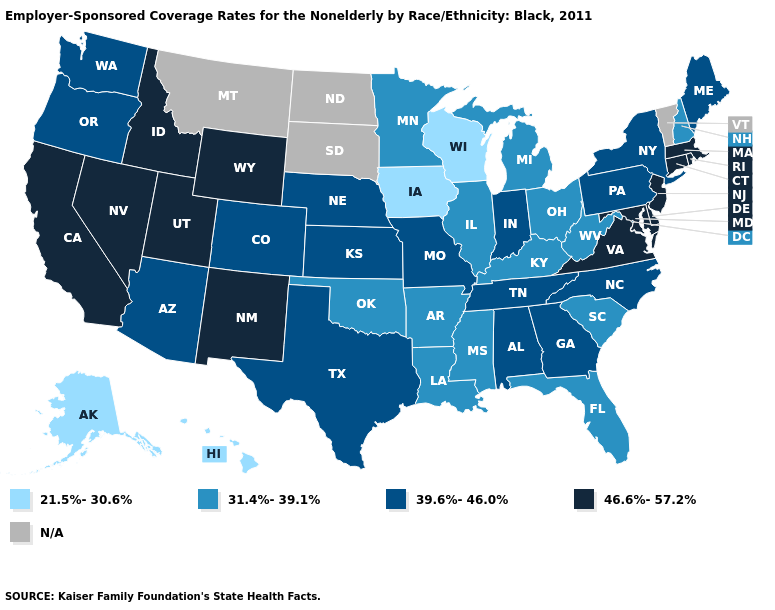Which states have the lowest value in the USA?
Keep it brief. Alaska, Hawaii, Iowa, Wisconsin. Among the states that border New Mexico , does Utah have the lowest value?
Keep it brief. No. How many symbols are there in the legend?
Quick response, please. 5. What is the value of North Carolina?
Short answer required. 39.6%-46.0%. Does Iowa have the lowest value in the USA?
Be succinct. Yes. What is the lowest value in states that border West Virginia?
Concise answer only. 31.4%-39.1%. Is the legend a continuous bar?
Give a very brief answer. No. Does Rhode Island have the lowest value in the USA?
Short answer required. No. What is the lowest value in states that border Vermont?
Answer briefly. 31.4%-39.1%. What is the value of Connecticut?
Give a very brief answer. 46.6%-57.2%. What is the value of Maryland?
Be succinct. 46.6%-57.2%. Among the states that border New Mexico , does Utah have the highest value?
Answer briefly. Yes. What is the value of Delaware?
Answer briefly. 46.6%-57.2%. What is the value of New York?
Concise answer only. 39.6%-46.0%. What is the value of New York?
Give a very brief answer. 39.6%-46.0%. 